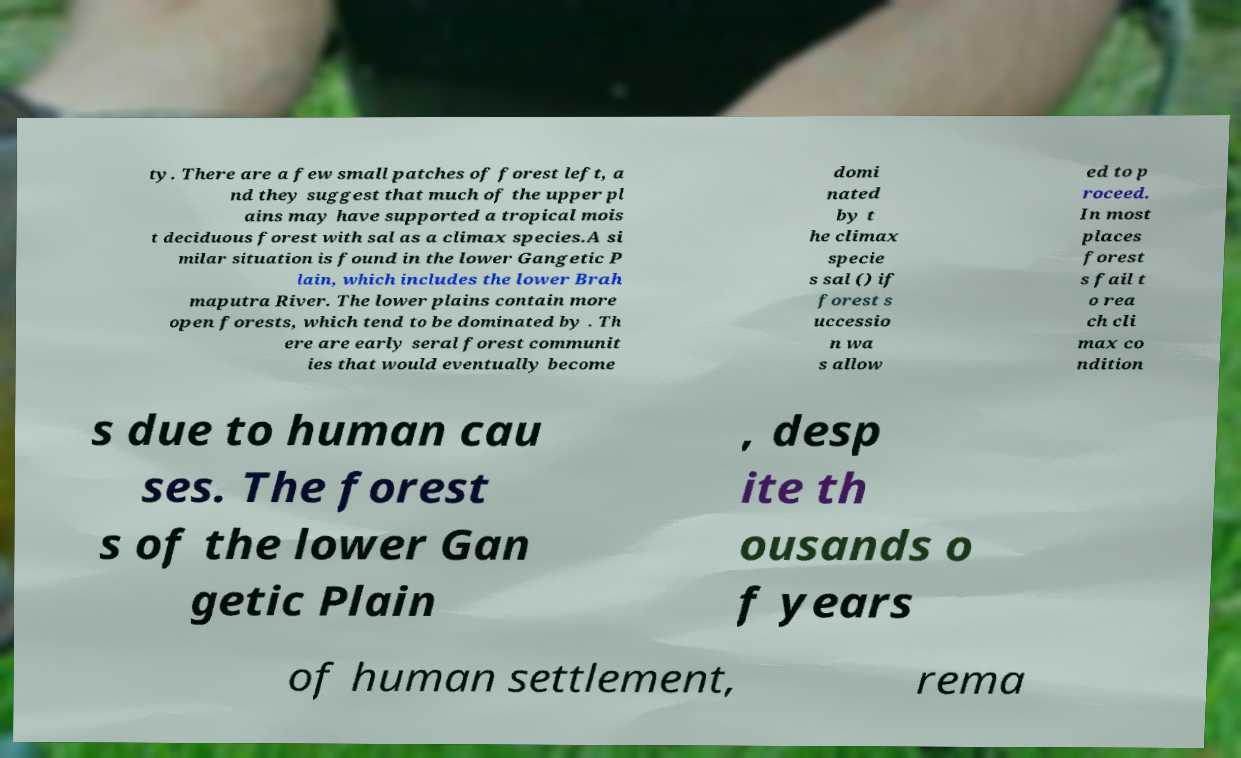Could you extract and type out the text from this image? ty. There are a few small patches of forest left, a nd they suggest that much of the upper pl ains may have supported a tropical mois t deciduous forest with sal as a climax species.A si milar situation is found in the lower Gangetic P lain, which includes the lower Brah maputra River. The lower plains contain more open forests, which tend to be dominated by . Th ere are early seral forest communit ies that would eventually become domi nated by t he climax specie s sal () if forest s uccessio n wa s allow ed to p roceed. In most places forest s fail t o rea ch cli max co ndition s due to human cau ses. The forest s of the lower Gan getic Plain , desp ite th ousands o f years of human settlement, rema 